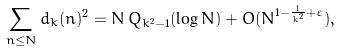<formula> <loc_0><loc_0><loc_500><loc_500>\sum _ { n \leq N } d _ { k } ( n ) ^ { 2 } = N \, Q _ { k ^ { 2 } - 1 } ( \log N ) + O ( N ^ { 1 - \frac { 1 } { k ^ { 2 } } + \varepsilon } ) ,</formula> 